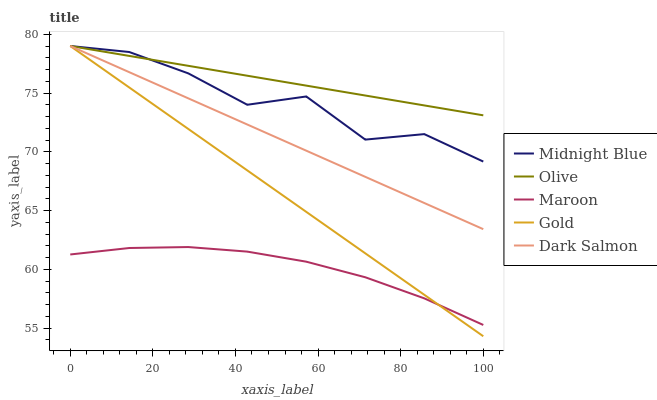Does Maroon have the minimum area under the curve?
Answer yes or no. Yes. Does Olive have the maximum area under the curve?
Answer yes or no. Yes. Does Gold have the minimum area under the curve?
Answer yes or no. No. Does Gold have the maximum area under the curve?
Answer yes or no. No. Is Dark Salmon the smoothest?
Answer yes or no. Yes. Is Midnight Blue the roughest?
Answer yes or no. Yes. Is Gold the smoothest?
Answer yes or no. No. Is Gold the roughest?
Answer yes or no. No. Does Gold have the lowest value?
Answer yes or no. Yes. Does Midnight Blue have the lowest value?
Answer yes or no. No. Does Dark Salmon have the highest value?
Answer yes or no. Yes. Does Maroon have the highest value?
Answer yes or no. No. Is Maroon less than Dark Salmon?
Answer yes or no. Yes. Is Dark Salmon greater than Maroon?
Answer yes or no. Yes. Does Maroon intersect Gold?
Answer yes or no. Yes. Is Maroon less than Gold?
Answer yes or no. No. Is Maroon greater than Gold?
Answer yes or no. No. Does Maroon intersect Dark Salmon?
Answer yes or no. No. 